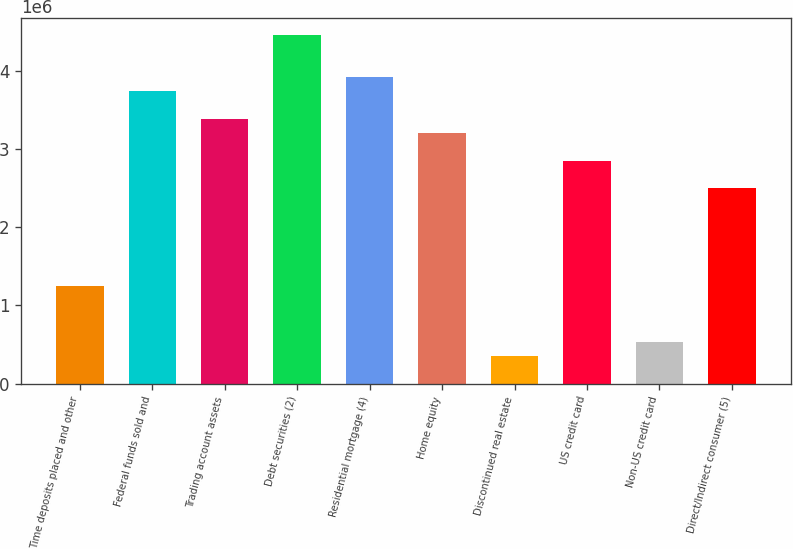<chart> <loc_0><loc_0><loc_500><loc_500><bar_chart><fcel>Time deposits placed and other<fcel>Federal funds sold and<fcel>Trading account assets<fcel>Debt securities (2)<fcel>Residential mortgage (4)<fcel>Home equity<fcel>Discontinued real estate<fcel>US credit card<fcel>Non-US credit card<fcel>Direct/Indirect consumer (5)<nl><fcel>1.24923e+06<fcel>3.74476e+06<fcel>3.38825e+06<fcel>4.45777e+06<fcel>3.92301e+06<fcel>3.21e+06<fcel>357970<fcel>2.8535e+06<fcel>536222<fcel>2.49699e+06<nl></chart> 